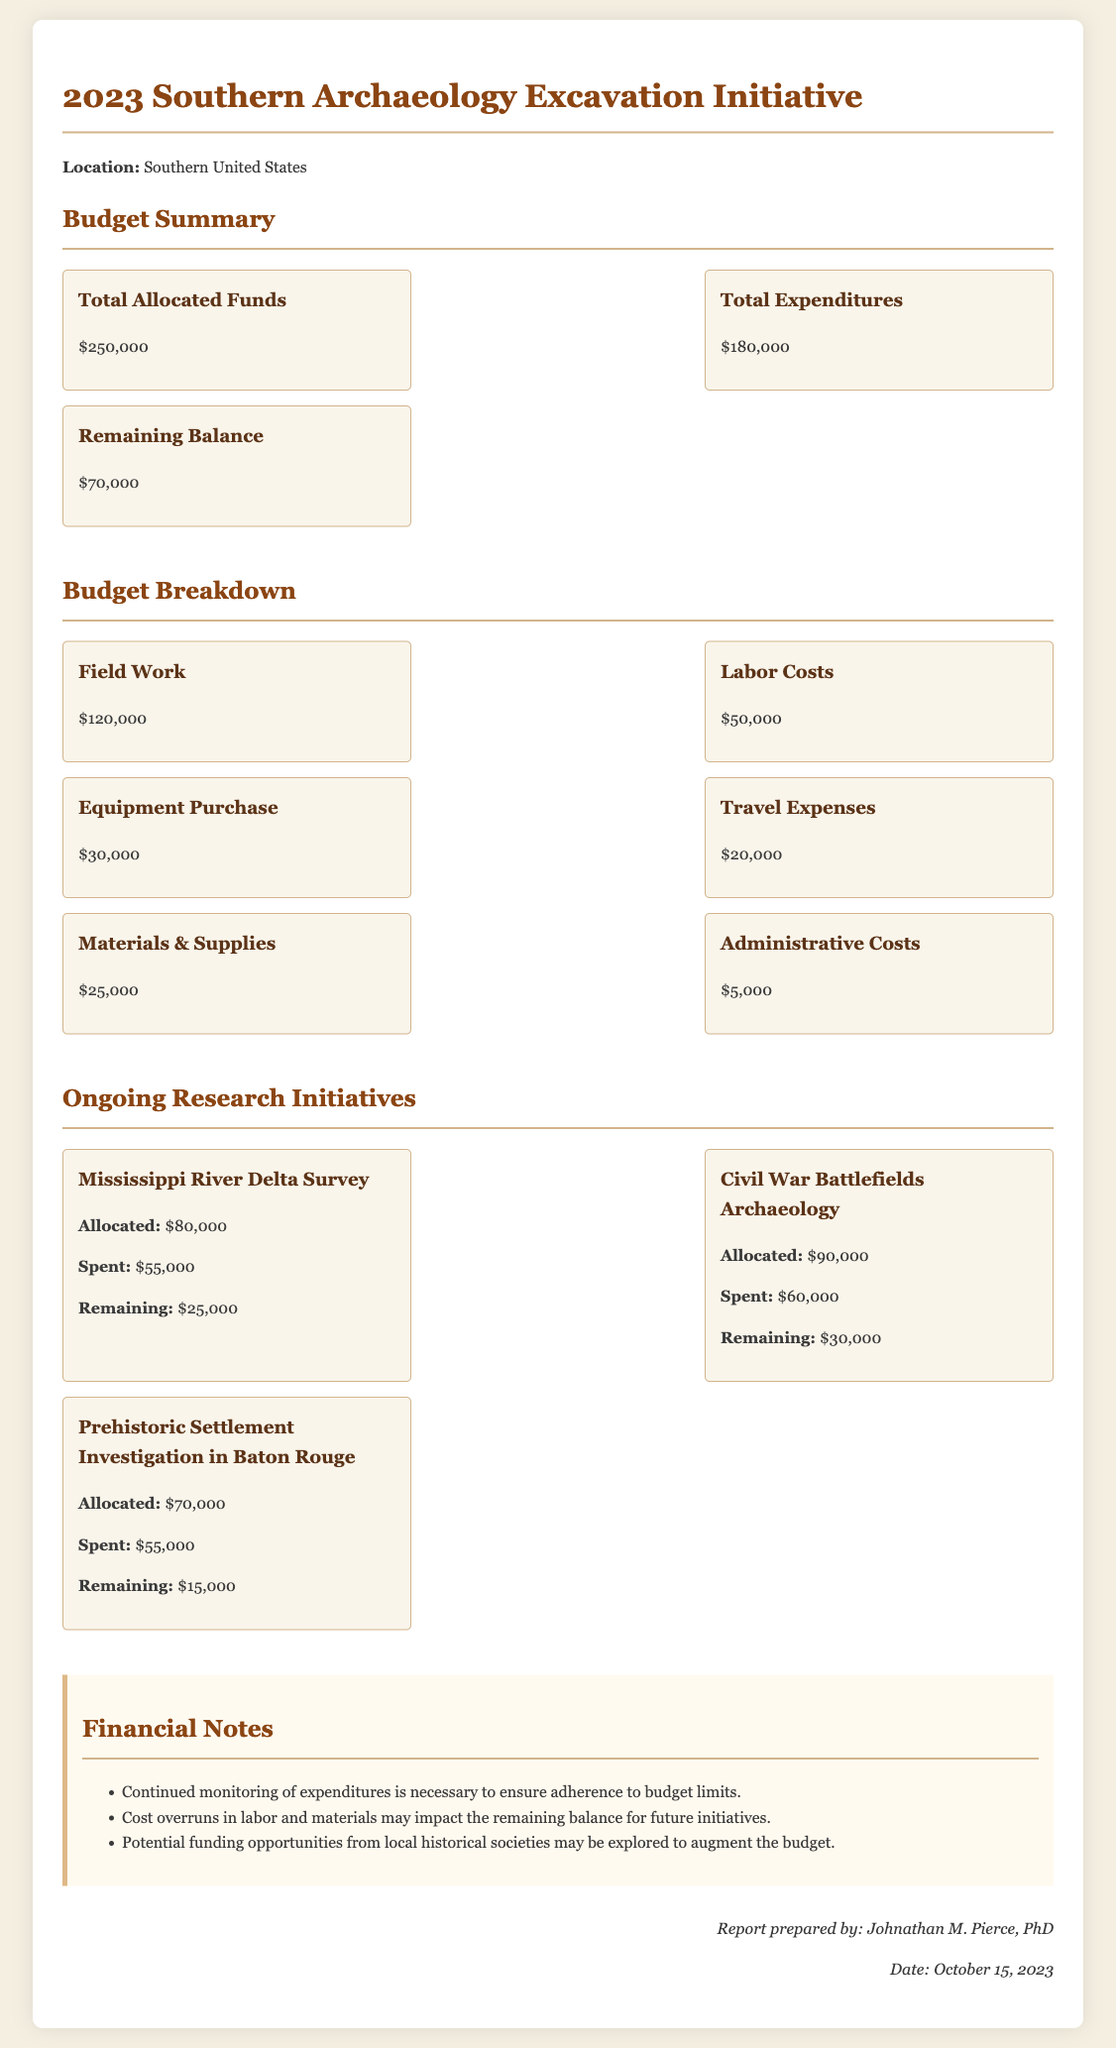What is the total allocated funds? The total allocated funds are stated in the budget summary section of the document, which lists it as $250,000.
Answer: $250,000 What is the total expenditures? The total expenditures are provided in the budget summary, reported as $180,000.
Answer: $180,000 What is the remaining balance? The remaining balance is derived from the budget summary, which indicates $70,000.
Answer: $70,000 How much is allocated for the Mississippi River Delta Survey? The allocated amount for the Mississippi River Delta Survey can be found in the ongoing research initiatives section, marked as $80,000.
Answer: $80,000 What is the spent amount on Prehistoric Settlement Investigation in Baton Rouge? The spent amount for the Prehistoric Settlement Investigation in Baton Rouge is given as $55,000 in the initiatives section.
Answer: $55,000 How much is allocated for labor costs? The allocated amount for labor costs is specified under the budget breakdown section as $50,000.
Answer: $50,000 What are the financial notes recommending? The financial notes suggest continued monitoring of expenditures as a key recommendation to manage the budget effectively.
Answer: Continued monitoring of expenditures Which initiative has the highest remaining funds? The initiative with the highest remaining funds can be calculated by comparing the remaining amounts for each initiative; the Civil War Battlefields Archaeology has $30,000 remaining.
Answer: Civil War Battlefields Archaeology Who prepared the report? The report was prepared by Johnathan M. Pierce, PhD, as indicated in the footer section of the document.
Answer: Johnathan M. Pierce, PhD 